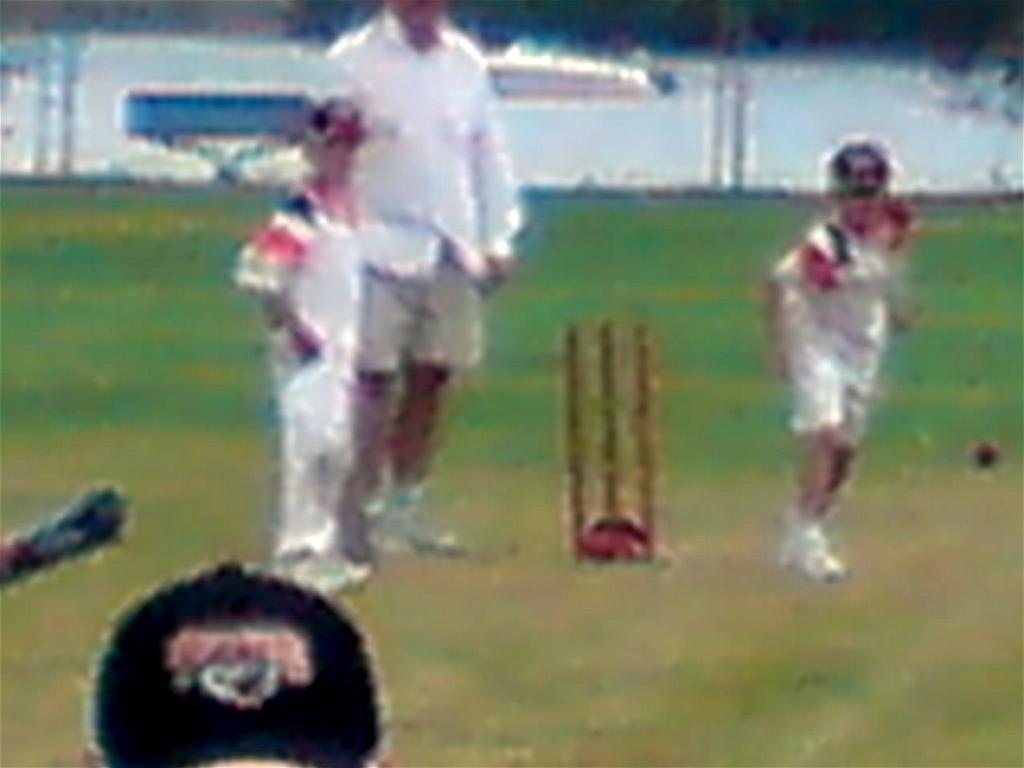How would you summarize this image in a sentence or two? In this image we can see some people and on the right side we can see wicket and there are many grasses on the ground and background is blurred. 